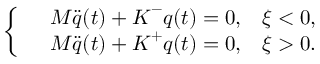Convert formula to latex. <formula><loc_0><loc_0><loc_500><loc_500>\left \{ \begin{array} { r l r } & { M \ddot { q } ( t ) + K ^ { - } q ( t ) = 0 , } & { \xi < 0 , } \\ & { M \ddot { q } ( t ) + K ^ { + } q ( t ) = 0 , } & { \xi > 0 . } \end{array}</formula> 